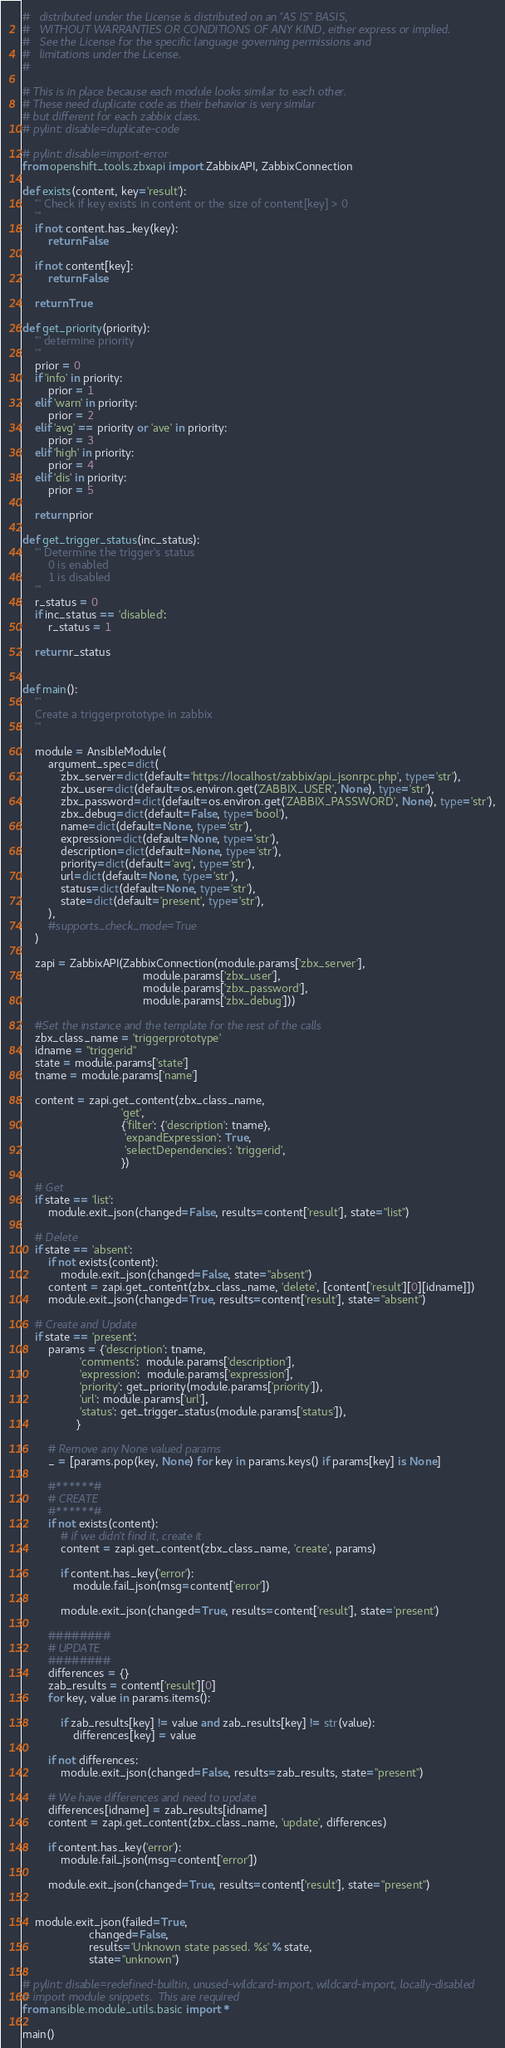<code> <loc_0><loc_0><loc_500><loc_500><_Python_>#   distributed under the License is distributed on an "AS IS" BASIS,
#   WITHOUT WARRANTIES OR CONDITIONS OF ANY KIND, either express or implied.
#   See the License for the specific language governing permissions and
#   limitations under the License.
#

# This is in place because each module looks similar to each other.
# These need duplicate code as their behavior is very similar
# but different for each zabbix class.
# pylint: disable=duplicate-code

# pylint: disable=import-error
from openshift_tools.zbxapi import ZabbixAPI, ZabbixConnection

def exists(content, key='result'):
    ''' Check if key exists in content or the size of content[key] > 0
    '''
    if not content.has_key(key):
        return False

    if not content[key]:
        return False

    return True

def get_priority(priority):
    ''' determine priority
    '''
    prior = 0
    if 'info' in priority:
        prior = 1
    elif 'warn' in priority:
        prior = 2
    elif 'avg' == priority or 'ave' in priority:
        prior = 3
    elif 'high' in priority:
        prior = 4
    elif 'dis' in priority:
        prior = 5

    return prior

def get_trigger_status(inc_status):
    ''' Determine the trigger's status
        0 is enabled
        1 is disabled
    '''
    r_status = 0
    if inc_status == 'disabled':
        r_status = 1

    return r_status


def main():
    '''
    Create a triggerprototype in zabbix
    '''

    module = AnsibleModule(
        argument_spec=dict(
            zbx_server=dict(default='https://localhost/zabbix/api_jsonrpc.php', type='str'),
            zbx_user=dict(default=os.environ.get('ZABBIX_USER', None), type='str'),
            zbx_password=dict(default=os.environ.get('ZABBIX_PASSWORD', None), type='str'),
            zbx_debug=dict(default=False, type='bool'),
            name=dict(default=None, type='str'),
            expression=dict(default=None, type='str'),
            description=dict(default=None, type='str'),
            priority=dict(default='avg', type='str'),
            url=dict(default=None, type='str'),
            status=dict(default=None, type='str'),
            state=dict(default='present', type='str'),
        ),
        #supports_check_mode=True
    )

    zapi = ZabbixAPI(ZabbixConnection(module.params['zbx_server'],
                                      module.params['zbx_user'],
                                      module.params['zbx_password'],
                                      module.params['zbx_debug']))

    #Set the instance and the template for the rest of the calls
    zbx_class_name = 'triggerprototype'
    idname = "triggerid"
    state = module.params['state']
    tname = module.params['name']

    content = zapi.get_content(zbx_class_name,
                               'get',
                               {'filter': {'description': tname},
                                'expandExpression': True,
                                'selectDependencies': 'triggerid',
                               })

    # Get
    if state == 'list':
        module.exit_json(changed=False, results=content['result'], state="list")

    # Delete
    if state == 'absent':
        if not exists(content):
            module.exit_json(changed=False, state="absent")
        content = zapi.get_content(zbx_class_name, 'delete', [content['result'][0][idname]])
        module.exit_json(changed=True, results=content['result'], state="absent")

    # Create and Update
    if state == 'present':
        params = {'description': tname,
                  'comments':  module.params['description'],
                  'expression':  module.params['expression'],
                  'priority': get_priority(module.params['priority']),
                  'url': module.params['url'],
                  'status': get_trigger_status(module.params['status']),
                 }

        # Remove any None valued params
        _ = [params.pop(key, None) for key in params.keys() if params[key] is None]

        #******#
        # CREATE
        #******#
        if not exists(content):
            # if we didn't find it, create it
            content = zapi.get_content(zbx_class_name, 'create', params)

            if content.has_key('error'):
                module.fail_json(msg=content['error'])

            module.exit_json(changed=True, results=content['result'], state='present')

        ########
        # UPDATE
        ########
        differences = {}
        zab_results = content['result'][0]
        for key, value in params.items():

            if zab_results[key] != value and zab_results[key] != str(value):
                differences[key] = value

        if not differences:
            module.exit_json(changed=False, results=zab_results, state="present")

        # We have differences and need to update
        differences[idname] = zab_results[idname]
        content = zapi.get_content(zbx_class_name, 'update', differences)

        if content.has_key('error'):
            module.fail_json(msg=content['error'])

        module.exit_json(changed=True, results=content['result'], state="present")


    module.exit_json(failed=True,
                     changed=False,
                     results='Unknown state passed. %s' % state,
                     state="unknown")

# pylint: disable=redefined-builtin, unused-wildcard-import, wildcard-import, locally-disabled
# import module snippets.  This are required
from ansible.module_utils.basic import *

main()
</code> 